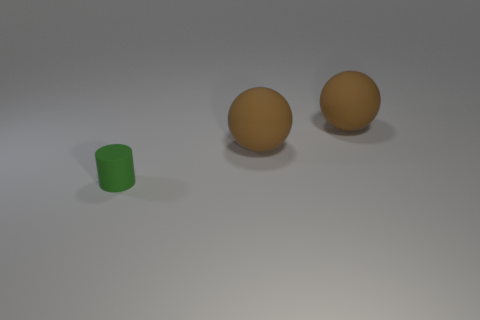Is there another small green cylinder that has the same material as the green cylinder?
Give a very brief answer. No. Are there an equal number of green rubber cylinders to the right of the tiny green rubber cylinder and large red cylinders?
Your response must be concise. Yes. How many spheres are either green things or big brown objects?
Keep it short and to the point. 2. What color is the tiny thing?
Give a very brief answer. Green. What number of things are objects that are behind the tiny matte thing or small things?
Provide a short and direct response. 3. How many things are either rubber objects that are behind the small rubber thing or things right of the small green thing?
Provide a succinct answer. 2. What number of other objects are there of the same color as the tiny rubber cylinder?
Ensure brevity in your answer.  0. There is a tiny green matte cylinder; what number of things are to the right of it?
Your response must be concise. 2. Are there any other tiny green rubber things that have the same shape as the green thing?
Offer a terse response. No. How many other green cylinders have the same material as the green cylinder?
Keep it short and to the point. 0. 